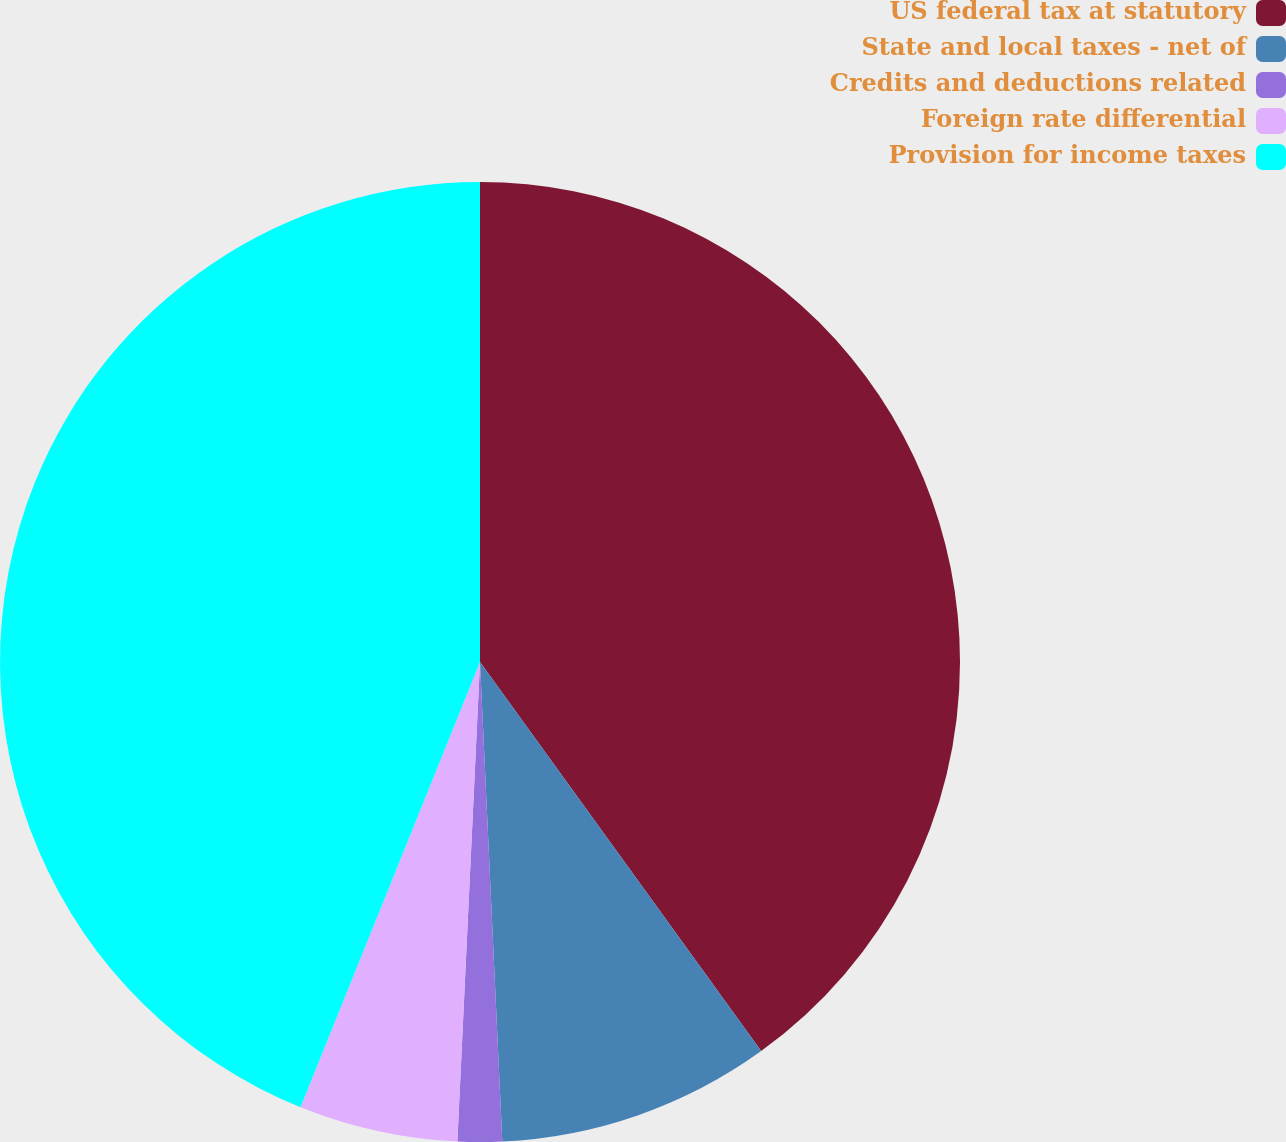Convert chart. <chart><loc_0><loc_0><loc_500><loc_500><pie_chart><fcel>US federal tax at statutory<fcel>State and local taxes - net of<fcel>Credits and deductions related<fcel>Foreign rate differential<fcel>Provision for income taxes<nl><fcel>40.04%<fcel>9.22%<fcel>1.49%<fcel>5.35%<fcel>43.9%<nl></chart> 